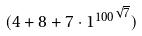Convert formula to latex. <formula><loc_0><loc_0><loc_500><loc_500>( 4 + 8 + 7 \cdot { 1 ^ { 1 0 0 } } ^ { \sqrt { 7 } } )</formula> 